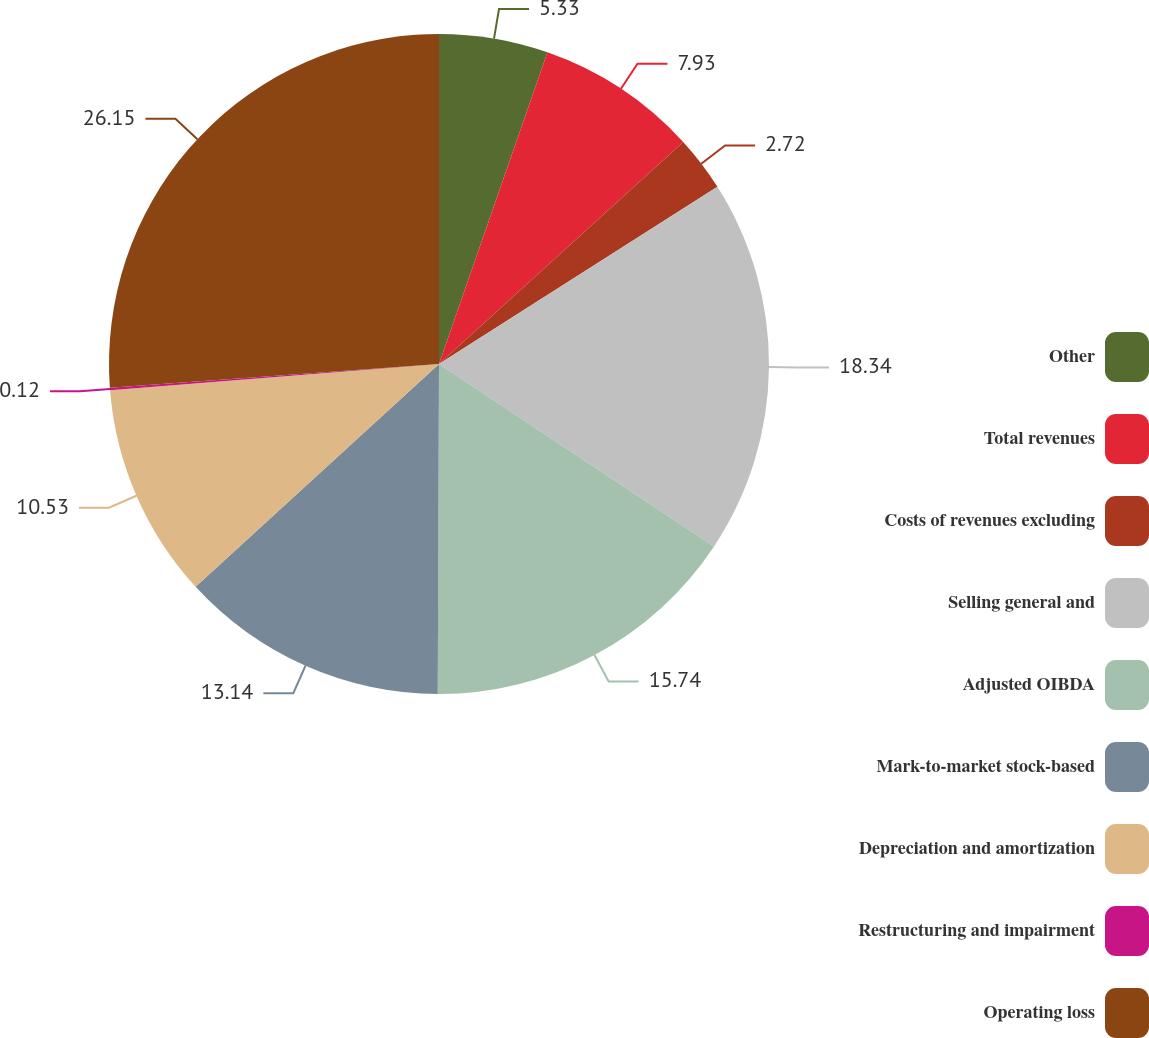<chart> <loc_0><loc_0><loc_500><loc_500><pie_chart><fcel>Other<fcel>Total revenues<fcel>Costs of revenues excluding<fcel>Selling general and<fcel>Adjusted OIBDA<fcel>Mark-to-market stock-based<fcel>Depreciation and amortization<fcel>Restructuring and impairment<fcel>Operating loss<nl><fcel>5.33%<fcel>7.93%<fcel>2.72%<fcel>18.34%<fcel>15.74%<fcel>13.14%<fcel>10.53%<fcel>0.12%<fcel>26.15%<nl></chart> 